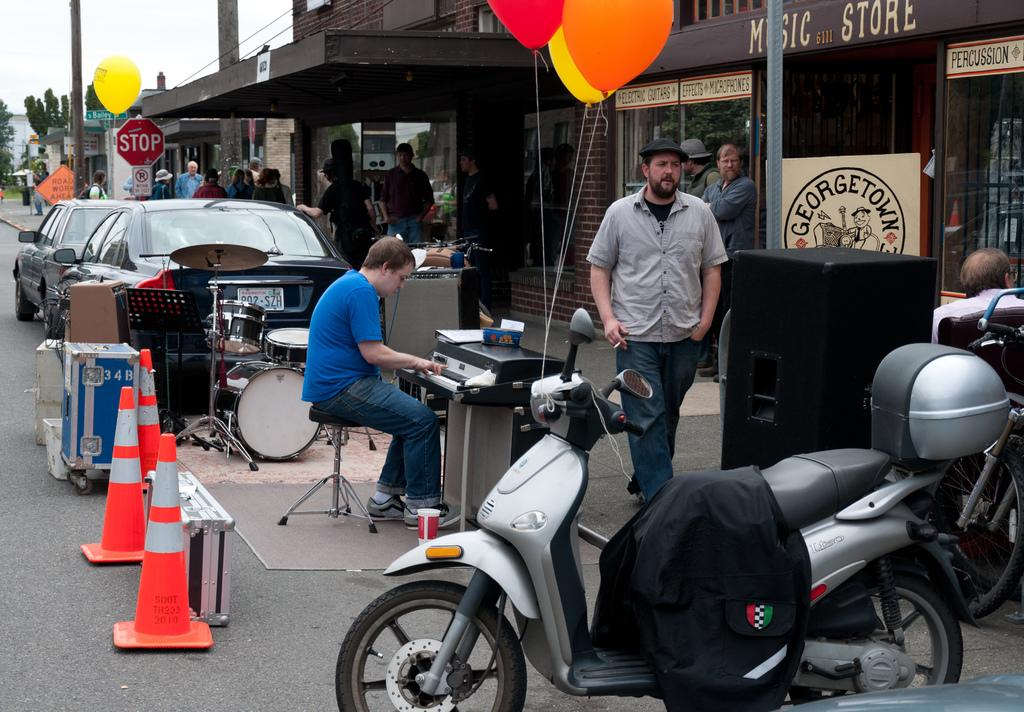What is the person in the image doing? The person in the image is playing musical instruments. What type of structures can be seen in the image? There are houses in the image. What type of vegetation is present in the image? There are trees in the image. How many people are visible in the image? There are people in the image. What type of transportation is present in the image? There are vehicles in the image. What decorative items can be seen in the image? There are balloons in the image. Where can the tomatoes be found in the image? There are no tomatoes present in the image. What type of cord is used to hang the balloons in the image? There is no mention of a cord or any method of hanging the balloons in the image. 